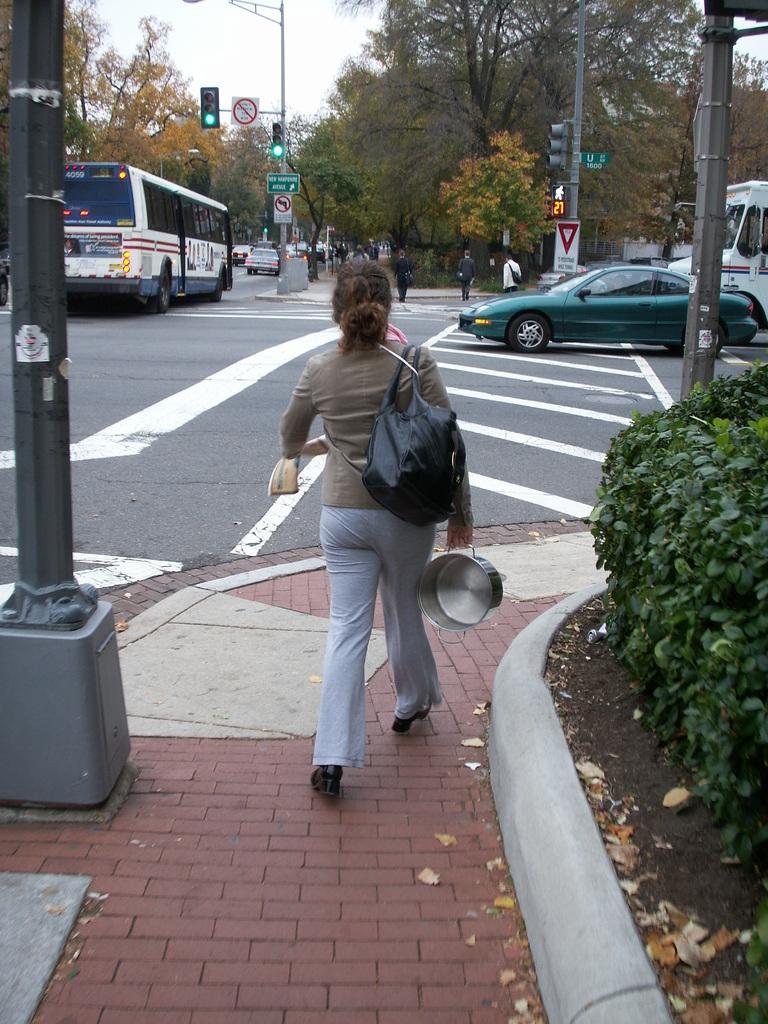In one or two sentences, can you explain what this image depicts? The image is outside of the city. In the image there are group of people walking, in middle of the image there is a woman wearing a handbag and holding a pan on her hand and walking on road. On right side there is a car and left side there is a bus and a pole,street lights and we can also see traffic signals,trees from right to left and sky is on top. 